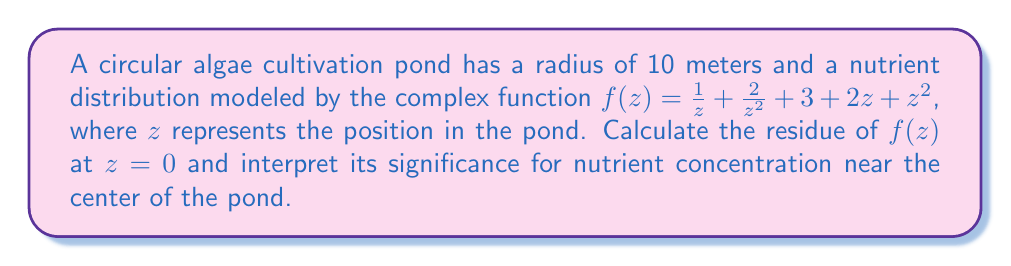Could you help me with this problem? To solve this problem, we'll follow these steps:

1) First, recall that the Laurent series of a function $f(z)$ around $z=0$ is of the form:

   $$f(z) = \sum_{n=-\infty}^{\infty} a_n z^n$$

2) In our case, we already have the function expressed in a form similar to a Laurent series:

   $$f(z) = \frac{1}{z} + \frac{2}{z^2} + 3 + 2z + z^2$$

3) The residue of $f(z)$ at $z=0$ is the coefficient of $\frac{1}{z}$ in the Laurent series expansion. In this case, it's simply the coefficient of the $\frac{1}{z}$ term.

4) From the given function, we can see that the coefficient of $\frac{1}{z}$ is 1.

5) Therefore, the residue of $f(z)$ at $z=0$ is 1.

Interpretation for nutrient concentration:
The residue at $z=0$ represents the circulation of nutrients around the center of the pond. A positive residue (as in this case) indicates a counterclockwise circulation of nutrients. The magnitude of the residue (1 in this case) suggests a moderate level of nutrient concentration near the center.

For a venture capitalist interested in algae cultivation, this information is crucial. It indicates that the nutrient distribution in the pond is not uniform, with a circulation pattern around the center. This could inform decisions about pond design, nutrient addition strategies, and algae harvesting techniques to optimize production efficiency.
Answer: The residue of $f(z)$ at $z=0$ is 1. 